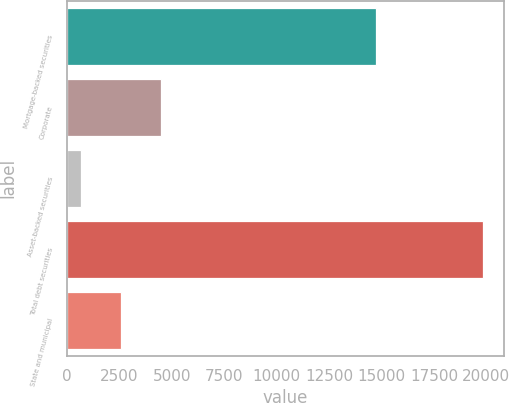Convert chart. <chart><loc_0><loc_0><loc_500><loc_500><bar_chart><fcel>Mortgage-backed securities<fcel>Corporate<fcel>Asset-backed securities<fcel>Total debt securities<fcel>State and municipal<nl><fcel>14749<fcel>4494.8<fcel>653<fcel>19862<fcel>2573.9<nl></chart> 